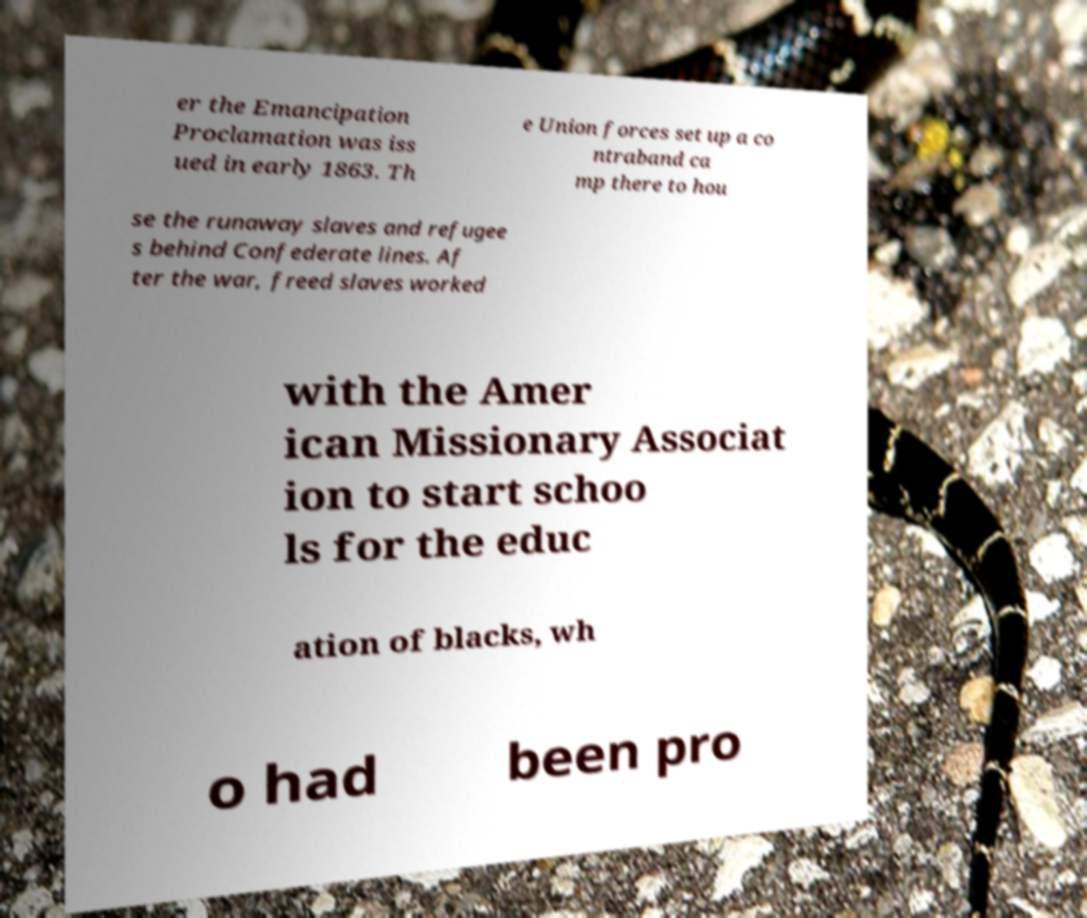Could you assist in decoding the text presented in this image and type it out clearly? er the Emancipation Proclamation was iss ued in early 1863. Th e Union forces set up a co ntraband ca mp there to hou se the runaway slaves and refugee s behind Confederate lines. Af ter the war, freed slaves worked with the Amer ican Missionary Associat ion to start schoo ls for the educ ation of blacks, wh o had been pro 